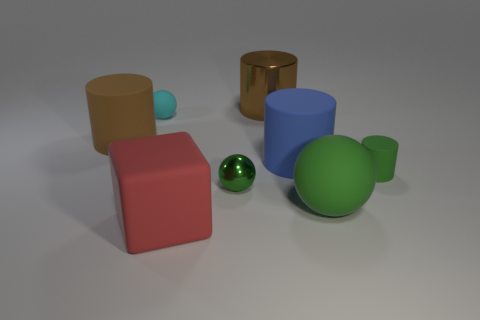Are there any green rubber balls that are behind the large cylinder behind the large brown matte thing?
Ensure brevity in your answer.  No. How many spheres are large red rubber objects or brown things?
Provide a succinct answer. 0. What size is the matte cylinder behind the big blue cylinder that is behind the sphere to the right of the small green ball?
Your answer should be compact. Large. Are there any tiny balls on the right side of the tiny rubber ball?
Offer a terse response. Yes. What shape is the big thing that is the same color as the tiny metallic object?
Offer a very short reply. Sphere. What number of things are either objects that are in front of the small cyan rubber ball or gray metal objects?
Provide a short and direct response. 6. There is a cyan ball that is made of the same material as the red thing; what is its size?
Your response must be concise. Small. There is a red rubber block; is it the same size as the matte sphere that is in front of the blue cylinder?
Keep it short and to the point. Yes. What is the color of the big rubber object that is in front of the blue rubber thing and on the left side of the large green thing?
Keep it short and to the point. Red. What number of things are big objects to the right of the blue matte thing or small balls behind the small green rubber thing?
Your answer should be compact. 2. 